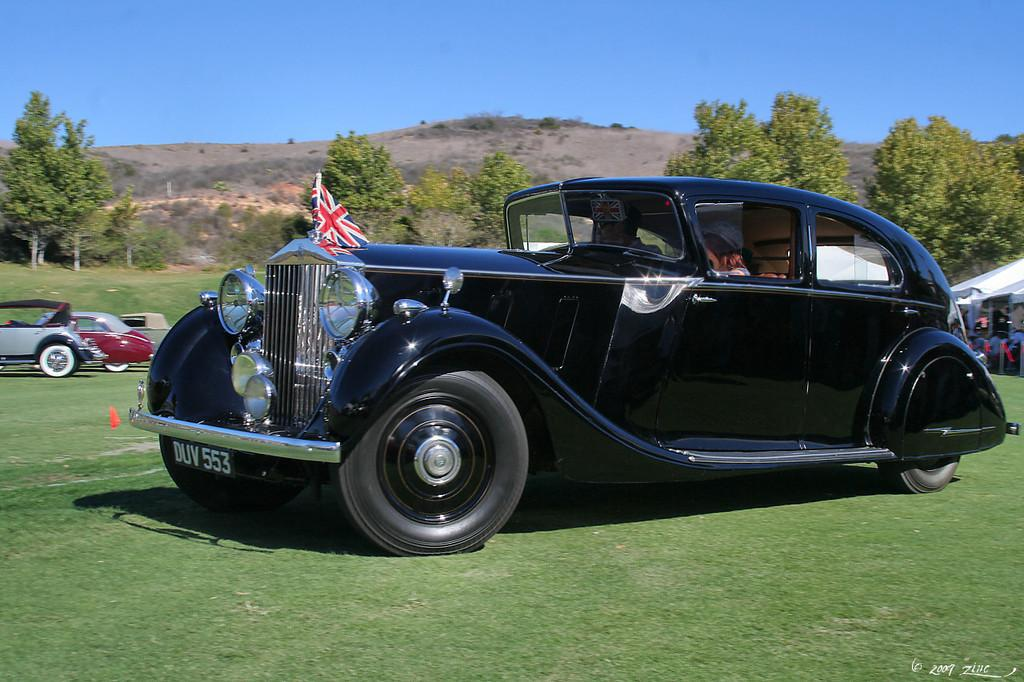What types of objects can be seen in the image? There are vehicles in the image. What natural elements are present in the image? There are trees, grass, and mountains in the image. What part of the natural environment is visible in the background of the image? The sky is visible in the background of the image. How many nails can be seen holding the mountains together in the image? There are no nails present in the image, as mountains are natural formations and not held together by nails. 